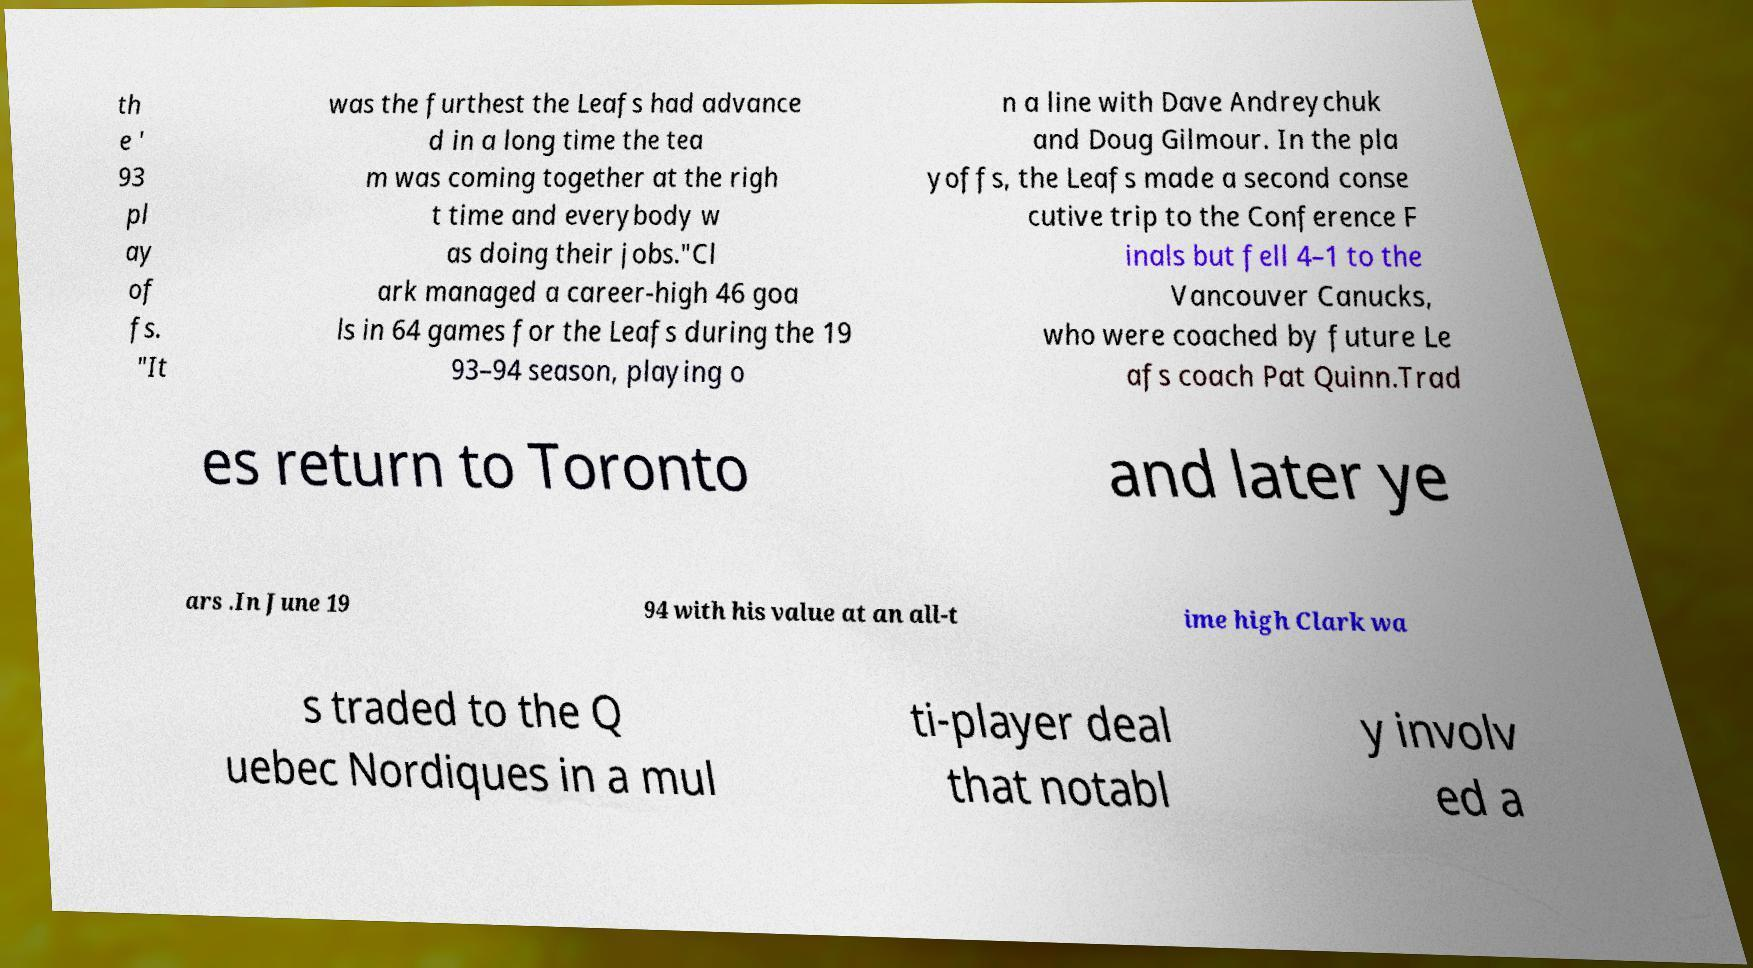Could you assist in decoding the text presented in this image and type it out clearly? th e ' 93 pl ay of fs. "It was the furthest the Leafs had advance d in a long time the tea m was coming together at the righ t time and everybody w as doing their jobs."Cl ark managed a career-high 46 goa ls in 64 games for the Leafs during the 19 93–94 season, playing o n a line with Dave Andreychuk and Doug Gilmour. In the pla yoffs, the Leafs made a second conse cutive trip to the Conference F inals but fell 4–1 to the Vancouver Canucks, who were coached by future Le afs coach Pat Quinn.Trad es return to Toronto and later ye ars .In June 19 94 with his value at an all-t ime high Clark wa s traded to the Q uebec Nordiques in a mul ti-player deal that notabl y involv ed a 